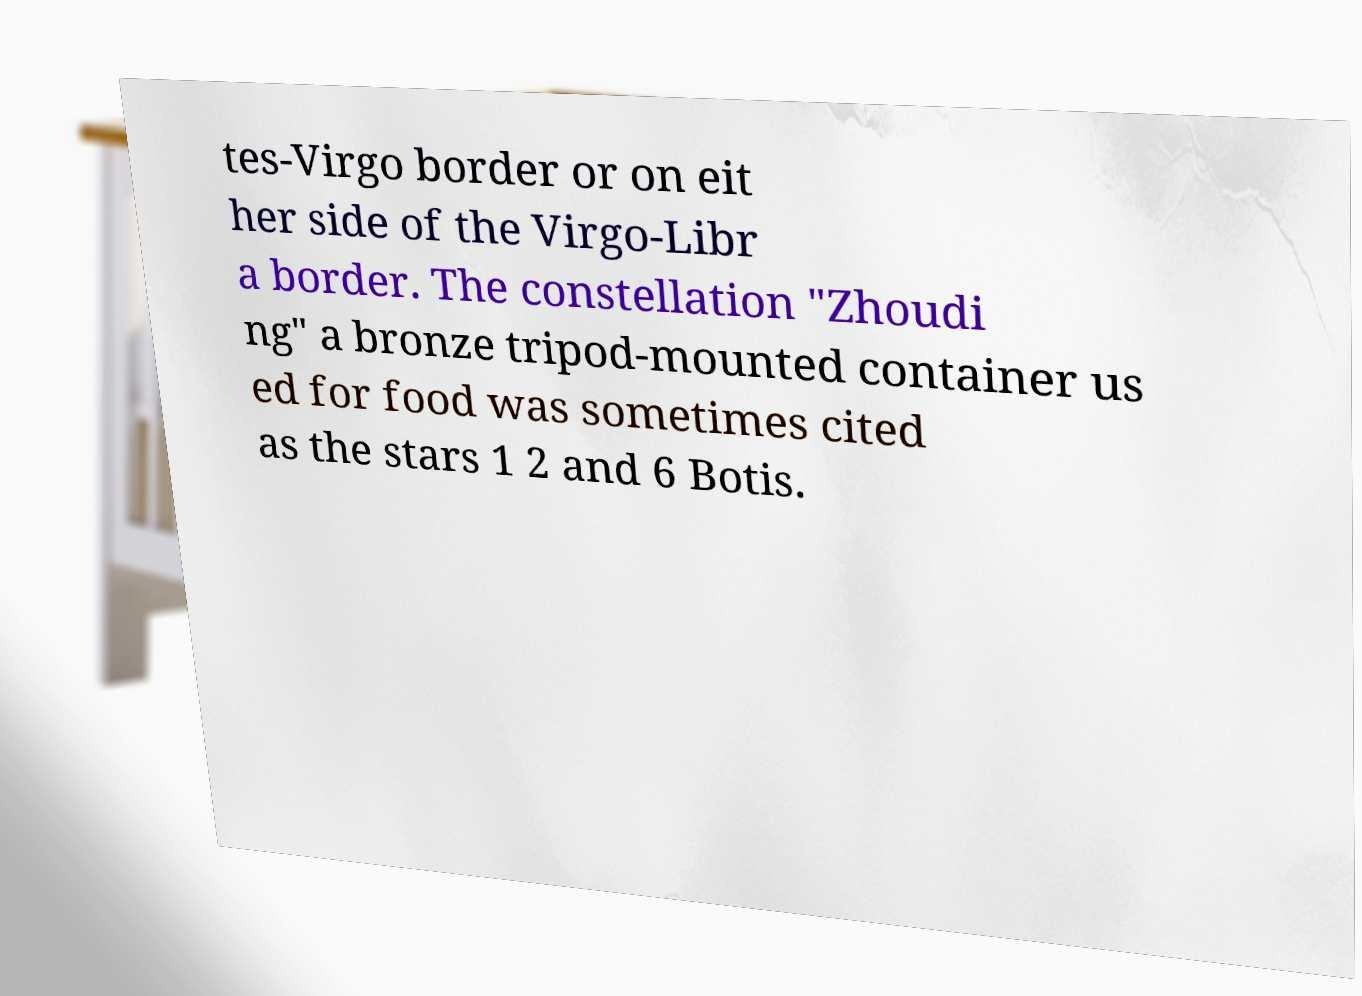Can you read and provide the text displayed in the image?This photo seems to have some interesting text. Can you extract and type it out for me? tes-Virgo border or on eit her side of the Virgo-Libr a border. The constellation "Zhoudi ng" a bronze tripod-mounted container us ed for food was sometimes cited as the stars 1 2 and 6 Botis. 